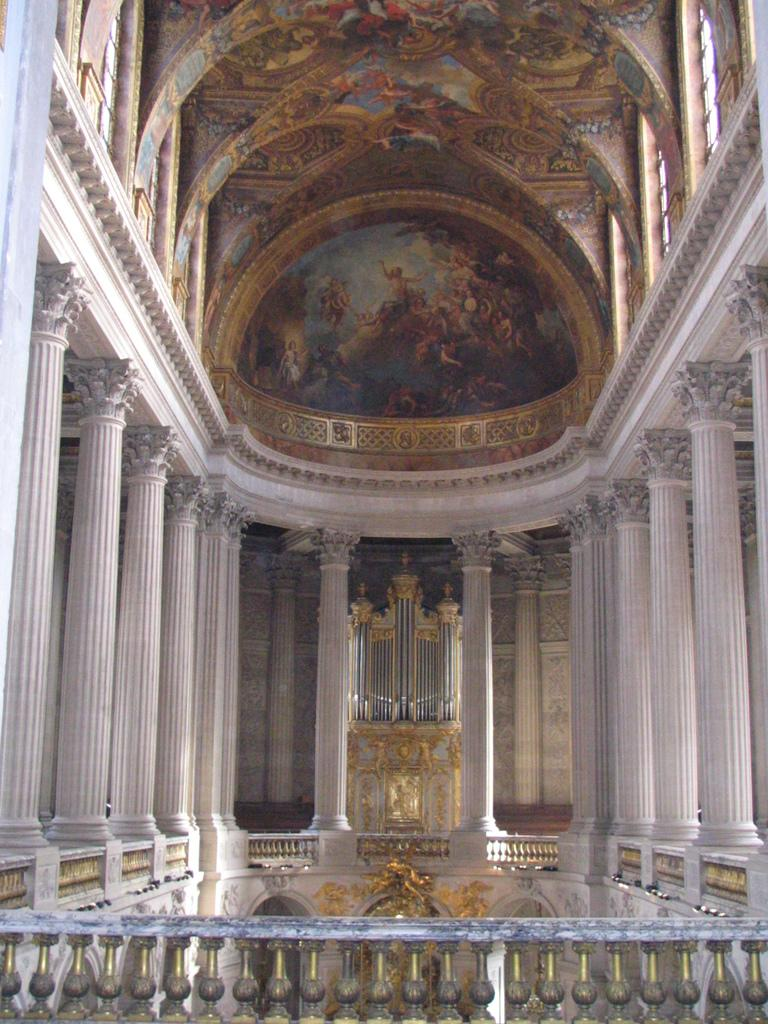What type of location is depicted in the image? The image is an inside view of a building. What architectural features can be seen on the sides of the building? There are pillars on the sides of the building. What decorative elements are present on the ceiling? There are paintings on the ceiling. What safety feature is present in the front of the building? There is a railing in the front of the building. How does the dirt contribute to the comfort of the building in the image? There is no dirt present in the image, and therefore it cannot contribute to the comfort of the building. 